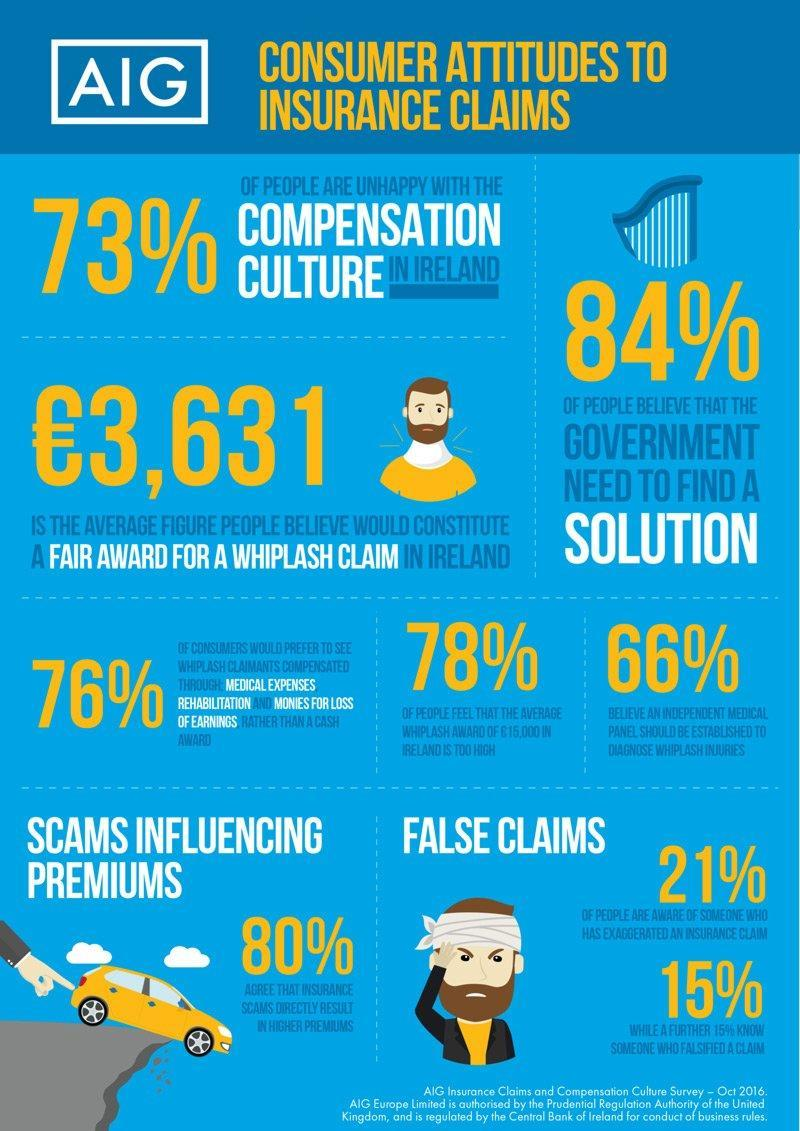What percentage of people are happy with the compensation culture in Ireland as per the survey in Oct 2016?
Answer the question with a short phrase. 27% What percentage of Irish people do not agree that insurance scams directly result in higher premiums as per the survey in Oct 2016? 20% What percentage of people feel that the average whiplash award of €15,000 in Ireland is too much as per the survey in Oct 2016? 78% 